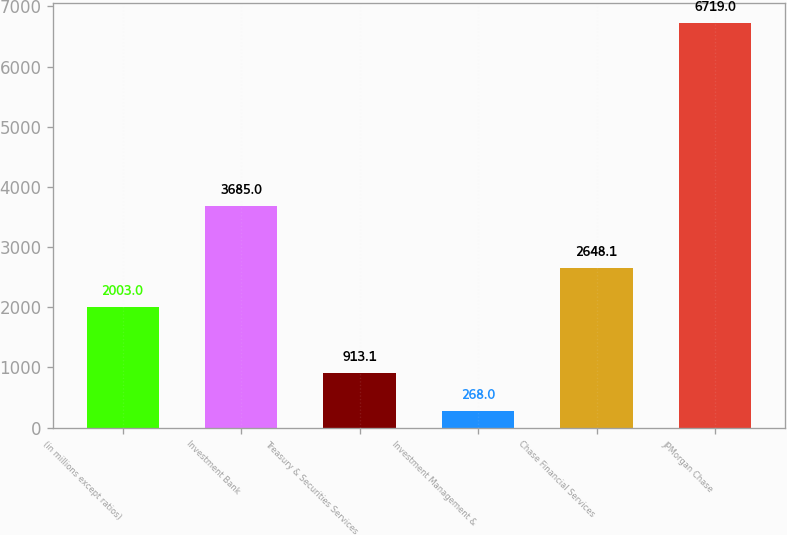<chart> <loc_0><loc_0><loc_500><loc_500><bar_chart><fcel>(in millions except ratios)<fcel>Investment Bank<fcel>Treasury & Securities Services<fcel>Investment Management &<fcel>Chase Financial Services<fcel>JPMorgan Chase<nl><fcel>2003<fcel>3685<fcel>913.1<fcel>268<fcel>2648.1<fcel>6719<nl></chart> 